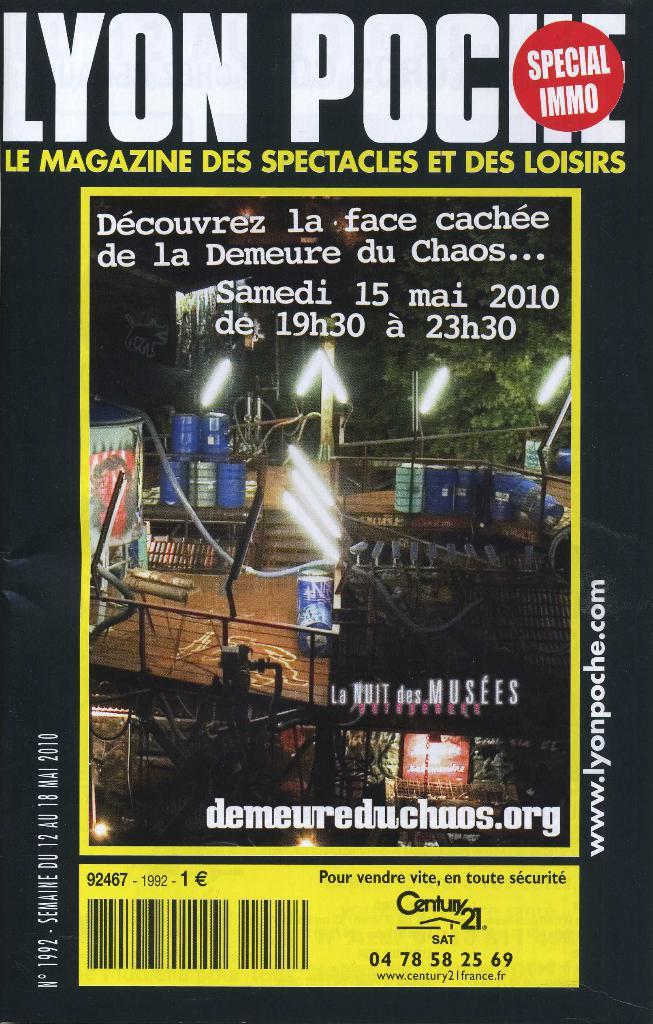What is the magazine title?
Give a very brief answer. Lyon poche. 